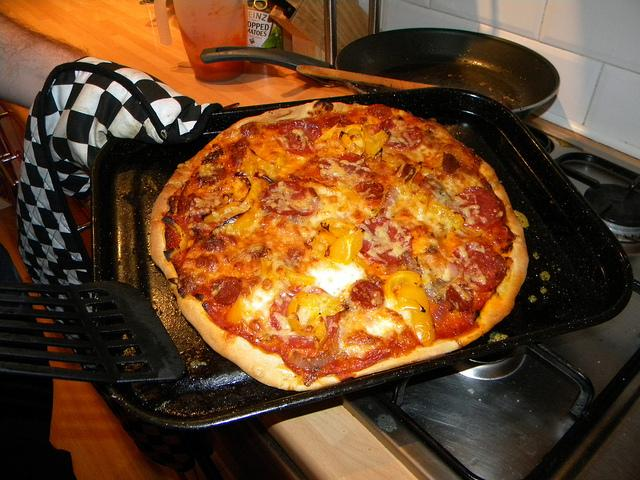The pizza came out of the oven powered by which fuel source? Please explain your reasoning. natural gas. The oven is using natural gas. 